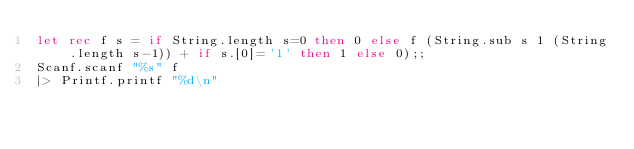<code> <loc_0><loc_0><loc_500><loc_500><_OCaml_>let rec f s = if String.length s=0 then 0 else f (String.sub s 1 (String.length s-1)) + if s.[0]='1' then 1 else 0);;
Scanf.scanf "%s" f
|> Printf.printf "%d\n"</code> 